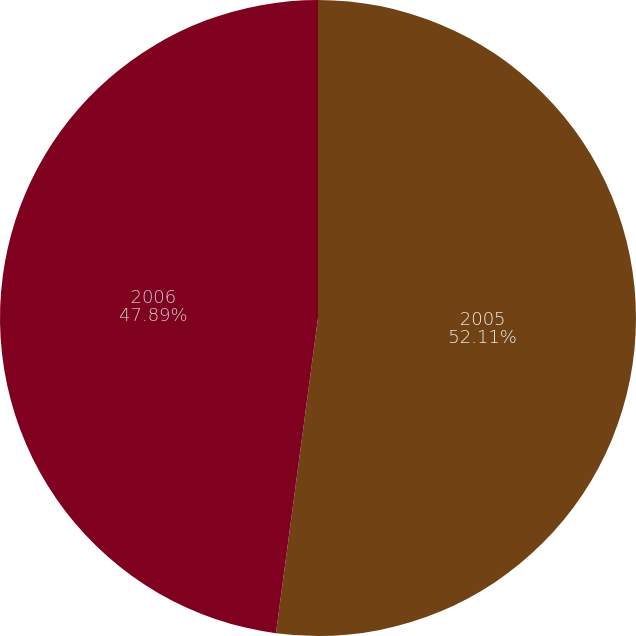<chart> <loc_0><loc_0><loc_500><loc_500><pie_chart><fcel>2005<fcel>2006<nl><fcel>52.11%<fcel>47.89%<nl></chart> 